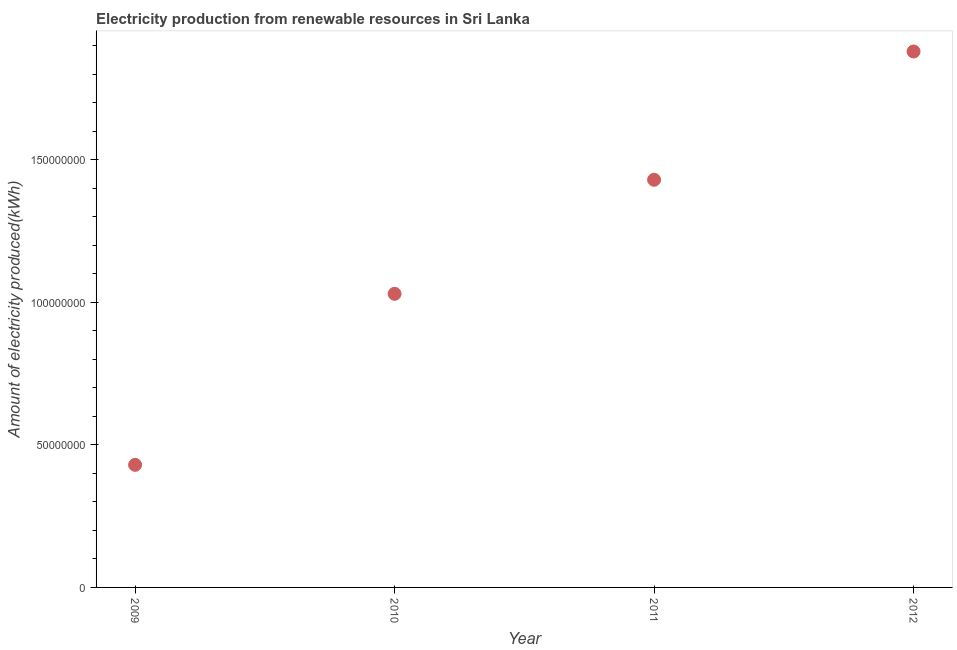What is the amount of electricity produced in 2009?
Keep it short and to the point. 4.30e+07. Across all years, what is the maximum amount of electricity produced?
Offer a very short reply. 1.88e+08. Across all years, what is the minimum amount of electricity produced?
Offer a very short reply. 4.30e+07. In which year was the amount of electricity produced minimum?
Make the answer very short. 2009. What is the sum of the amount of electricity produced?
Provide a succinct answer. 4.77e+08. What is the difference between the amount of electricity produced in 2009 and 2012?
Give a very brief answer. -1.45e+08. What is the average amount of electricity produced per year?
Your answer should be compact. 1.19e+08. What is the median amount of electricity produced?
Give a very brief answer. 1.23e+08. In how many years, is the amount of electricity produced greater than 150000000 kWh?
Provide a succinct answer. 1. Do a majority of the years between 2010 and 2011 (inclusive) have amount of electricity produced greater than 130000000 kWh?
Offer a terse response. No. What is the ratio of the amount of electricity produced in 2009 to that in 2012?
Offer a very short reply. 0.23. Is the amount of electricity produced in 2009 less than that in 2012?
Offer a terse response. Yes. Is the difference between the amount of electricity produced in 2009 and 2012 greater than the difference between any two years?
Your answer should be compact. Yes. What is the difference between the highest and the second highest amount of electricity produced?
Your answer should be very brief. 4.50e+07. What is the difference between the highest and the lowest amount of electricity produced?
Give a very brief answer. 1.45e+08. In how many years, is the amount of electricity produced greater than the average amount of electricity produced taken over all years?
Your response must be concise. 2. How many years are there in the graph?
Make the answer very short. 4. Does the graph contain any zero values?
Offer a very short reply. No. What is the title of the graph?
Offer a very short reply. Electricity production from renewable resources in Sri Lanka. What is the label or title of the X-axis?
Make the answer very short. Year. What is the label or title of the Y-axis?
Ensure brevity in your answer.  Amount of electricity produced(kWh). What is the Amount of electricity produced(kWh) in 2009?
Provide a short and direct response. 4.30e+07. What is the Amount of electricity produced(kWh) in 2010?
Make the answer very short. 1.03e+08. What is the Amount of electricity produced(kWh) in 2011?
Your answer should be very brief. 1.43e+08. What is the Amount of electricity produced(kWh) in 2012?
Provide a short and direct response. 1.88e+08. What is the difference between the Amount of electricity produced(kWh) in 2009 and 2010?
Provide a short and direct response. -6.00e+07. What is the difference between the Amount of electricity produced(kWh) in 2009 and 2011?
Give a very brief answer. -1.00e+08. What is the difference between the Amount of electricity produced(kWh) in 2009 and 2012?
Your answer should be very brief. -1.45e+08. What is the difference between the Amount of electricity produced(kWh) in 2010 and 2011?
Offer a very short reply. -4.00e+07. What is the difference between the Amount of electricity produced(kWh) in 2010 and 2012?
Offer a very short reply. -8.50e+07. What is the difference between the Amount of electricity produced(kWh) in 2011 and 2012?
Provide a short and direct response. -4.50e+07. What is the ratio of the Amount of electricity produced(kWh) in 2009 to that in 2010?
Your answer should be compact. 0.42. What is the ratio of the Amount of electricity produced(kWh) in 2009 to that in 2011?
Keep it short and to the point. 0.3. What is the ratio of the Amount of electricity produced(kWh) in 2009 to that in 2012?
Offer a terse response. 0.23. What is the ratio of the Amount of electricity produced(kWh) in 2010 to that in 2011?
Your answer should be compact. 0.72. What is the ratio of the Amount of electricity produced(kWh) in 2010 to that in 2012?
Make the answer very short. 0.55. What is the ratio of the Amount of electricity produced(kWh) in 2011 to that in 2012?
Your answer should be very brief. 0.76. 